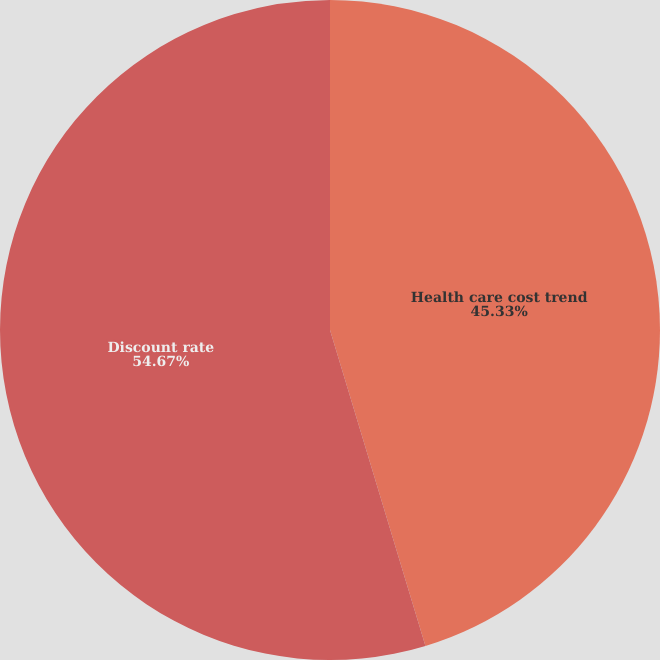<chart> <loc_0><loc_0><loc_500><loc_500><pie_chart><fcel>Health care cost trend<fcel>Discount rate<nl><fcel>45.33%<fcel>54.67%<nl></chart> 